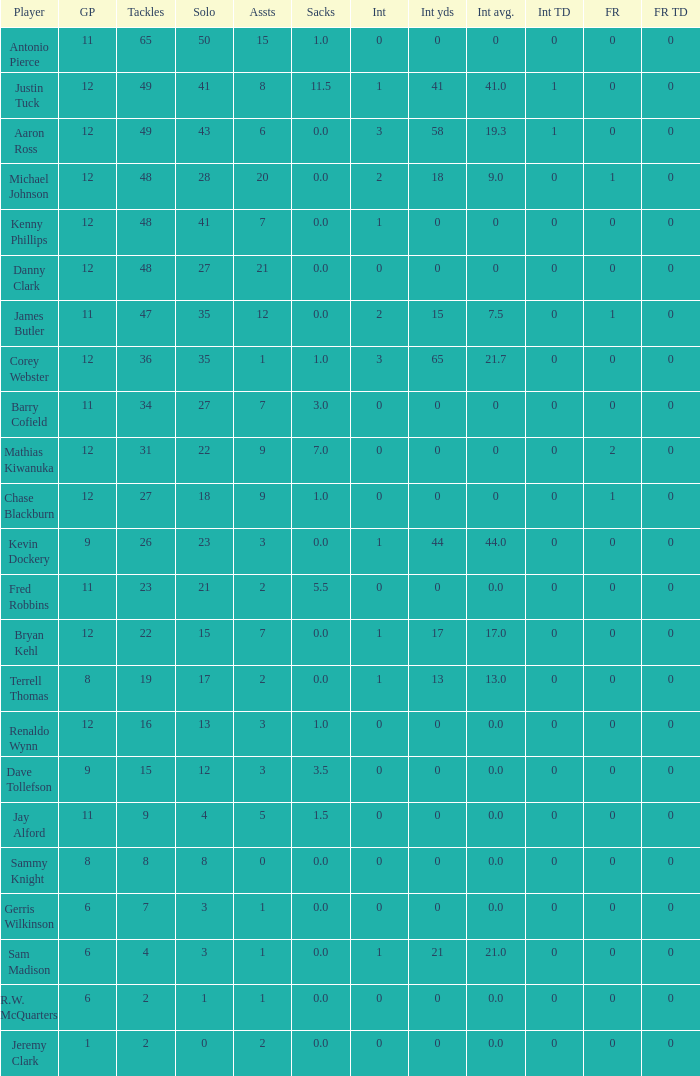Name the least amount of int yards 0.0. 